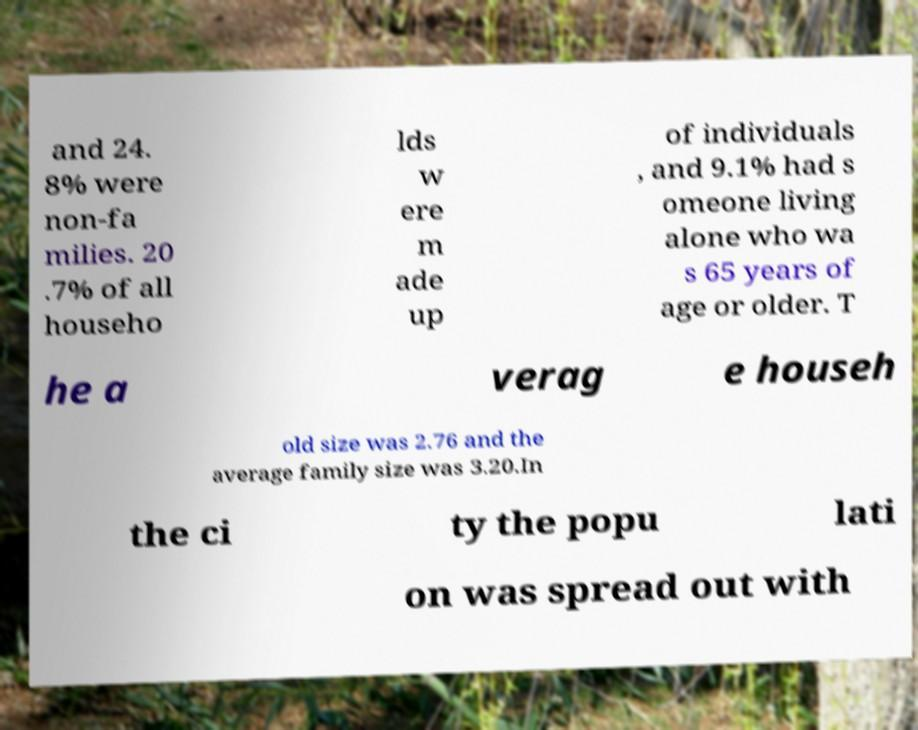Can you read and provide the text displayed in the image?This photo seems to have some interesting text. Can you extract and type it out for me? and 24. 8% were non-fa milies. 20 .7% of all househo lds w ere m ade up of individuals , and 9.1% had s omeone living alone who wa s 65 years of age or older. T he a verag e househ old size was 2.76 and the average family size was 3.20.In the ci ty the popu lati on was spread out with 